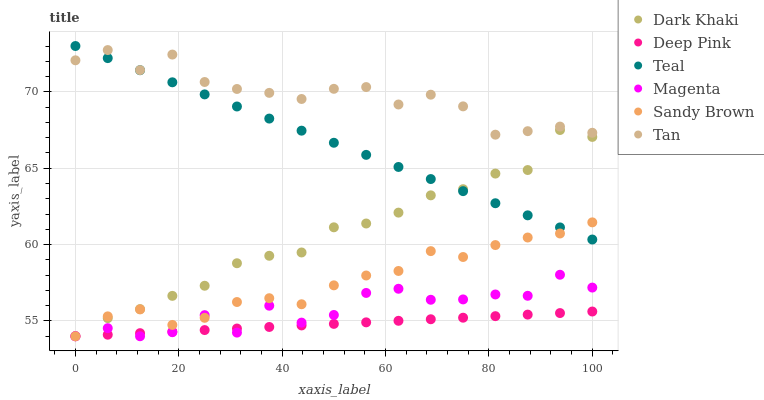Does Deep Pink have the minimum area under the curve?
Answer yes or no. Yes. Does Tan have the maximum area under the curve?
Answer yes or no. Yes. Does Dark Khaki have the minimum area under the curve?
Answer yes or no. No. Does Dark Khaki have the maximum area under the curve?
Answer yes or no. No. Is Teal the smoothest?
Answer yes or no. Yes. Is Magenta the roughest?
Answer yes or no. Yes. Is Dark Khaki the smoothest?
Answer yes or no. No. Is Dark Khaki the roughest?
Answer yes or no. No. Does Deep Pink have the lowest value?
Answer yes or no. Yes. Does Teal have the lowest value?
Answer yes or no. No. Does Teal have the highest value?
Answer yes or no. Yes. Does Dark Khaki have the highest value?
Answer yes or no. No. Is Dark Khaki less than Tan?
Answer yes or no. Yes. Is Tan greater than Sandy Brown?
Answer yes or no. Yes. Does Sandy Brown intersect Magenta?
Answer yes or no. Yes. Is Sandy Brown less than Magenta?
Answer yes or no. No. Is Sandy Brown greater than Magenta?
Answer yes or no. No. Does Dark Khaki intersect Tan?
Answer yes or no. No. 